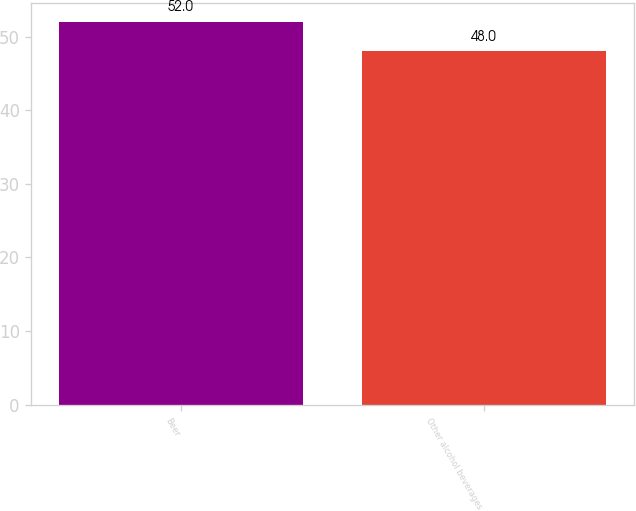<chart> <loc_0><loc_0><loc_500><loc_500><bar_chart><fcel>Beer<fcel>Other alcohol beverages<nl><fcel>52<fcel>48<nl></chart> 